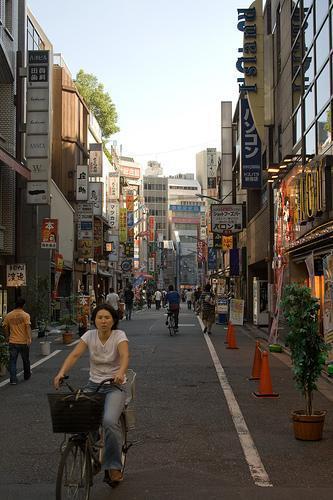How many cone you see in the picture?
Give a very brief answer. 3. How many people are on bikes?
Give a very brief answer. 2. How many trees are there?
Give a very brief answer. 2. How many people are in the picture?
Give a very brief answer. 1. 